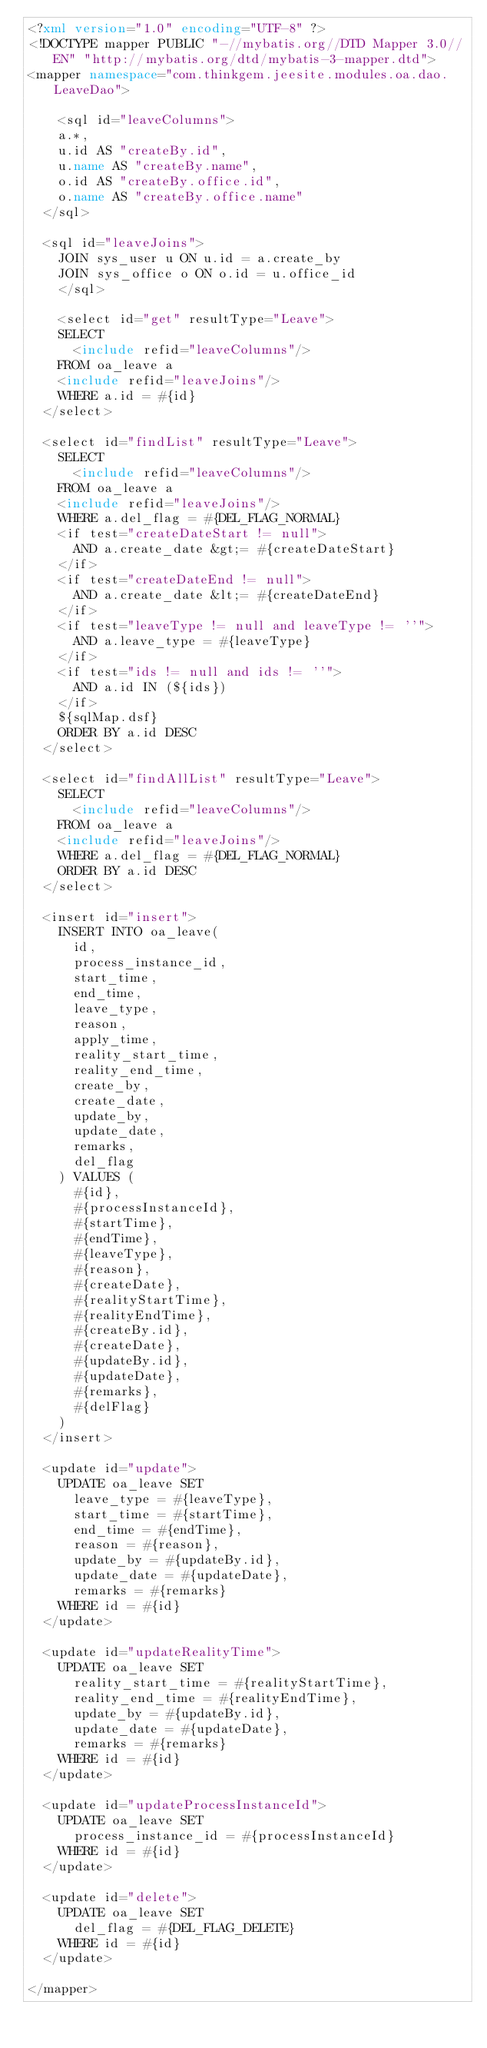Convert code to text. <code><loc_0><loc_0><loc_500><loc_500><_XML_><?xml version="1.0" encoding="UTF-8" ?>
<!DOCTYPE mapper PUBLIC "-//mybatis.org//DTD Mapper 3.0//EN" "http://mybatis.org/dtd/mybatis-3-mapper.dtd">
<mapper namespace="com.thinkgem.jeesite.modules.oa.dao.LeaveDao">
	
    <sql id="leaveColumns">
		a.*,
		u.id AS "createBy.id",
		u.name AS "createBy.name",
		o.id AS "createBy.office.id",
		o.name AS "createBy.office.name"
	</sql>
	
	<sql id="leaveJoins">
		JOIN sys_user u ON u.id = a.create_by
		JOIN sys_office o ON o.id = u.office_id
    </sql>
    
    <select id="get" resultType="Leave">
		SELECT 
			<include refid="leaveColumns"/>
		FROM oa_leave a
		<include refid="leaveJoins"/>
		WHERE a.id = #{id}
	</select>
	
	<select id="findList" resultType="Leave">
		SELECT 
			<include refid="leaveColumns"/>
		FROM oa_leave a
		<include refid="leaveJoins"/>
		WHERE a.del_flag = #{DEL_FLAG_NORMAL} 
		<if test="createDateStart != null">
			AND a.create_date &gt;= #{createDateStart}
		</if>
		<if test="createDateEnd != null">
			AND a.create_date &lt;= #{createDateEnd}
		</if>
		<if test="leaveType != null and leaveType != ''">
			AND a.leave_type = #{leaveType}
		</if>
		<if test="ids != null and ids != ''">
			AND a.id IN (${ids})
		</if>
		${sqlMap.dsf}
		ORDER BY a.id DESC
	</select>
	
	<select id="findAllList" resultType="Leave">
		SELECT 
			<include refid="leaveColumns"/>
		FROM oa_leave a
		<include refid="leaveJoins"/>
		WHERE a.del_flag = #{DEL_FLAG_NORMAL} 
		ORDER BY a.id DESC
	</select>
	
	<insert id="insert">
		INSERT INTO oa_leave(
			id, 
			process_instance_id, 
			start_time, 
			end_time, 
			leave_type, 
			reason, 
			apply_time, 
			reality_start_time, 
			reality_end_time, 
			create_by, 
			create_date, 
			update_by, 
			update_date, 
			remarks, 
			del_flag
		) VALUES (
			#{id}, 
			#{processInstanceId}, 
			#{startTime}, 
			#{endTime}, 
			#{leaveType}, 
			#{reason}, 
			#{createDate}, 
			#{realityStartTime}, 
			#{realityEndTime}, 
			#{createBy.id}, 
			#{createDate}, 
			#{updateBy.id}, 
			#{updateDate}, 
			#{remarks}, 
			#{delFlag}
		)
	</insert>
	
	<update id="update">
		UPDATE oa_leave SET 
			leave_type = #{leaveType}, 
			start_time = #{startTime}, 
			end_time = #{endTime}, 
			reason = #{reason}, 
			update_by = #{updateBy.id}, 
			update_date = #{updateDate}, 
			remarks = #{remarks}
		WHERE id = #{id}
	</update>
	
	<update id="updateRealityTime">
		UPDATE oa_leave SET 
			reality_start_time = #{realityStartTime}, 
			reality_end_time = #{realityEndTime}, 
			update_by = #{updateBy.id}, 
			update_date = #{updateDate}, 
			remarks = #{remarks}
		WHERE id = #{id}
	</update>
		
	<update id="updateProcessInstanceId">
		UPDATE oa_leave SET 
			process_instance_id = #{processInstanceId}
		WHERE id = #{id}
	</update>
	
	<update id="delete">
		UPDATE oa_leave SET 
			del_flag = #{DEL_FLAG_DELETE}
		WHERE id = #{id}
	</update>
	
</mapper></code> 